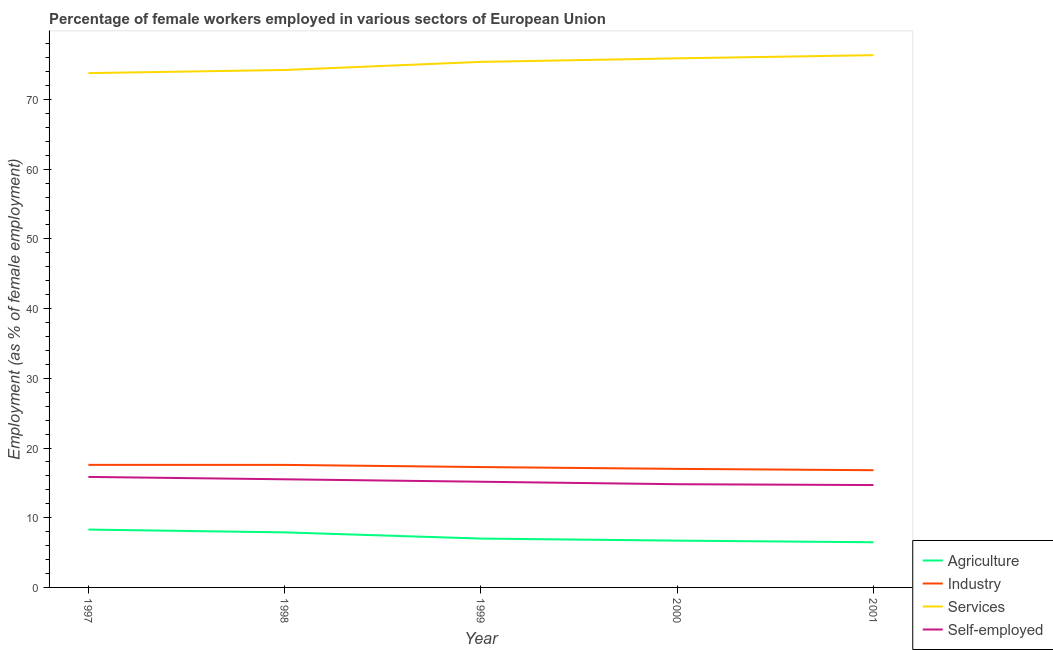How many different coloured lines are there?
Your answer should be very brief. 4. Is the number of lines equal to the number of legend labels?
Provide a succinct answer. Yes. What is the percentage of female workers in agriculture in 1998?
Your answer should be compact. 7.9. Across all years, what is the maximum percentage of female workers in agriculture?
Give a very brief answer. 8.3. Across all years, what is the minimum percentage of female workers in agriculture?
Ensure brevity in your answer.  6.48. In which year was the percentage of female workers in services maximum?
Offer a very short reply. 2001. What is the total percentage of female workers in industry in the graph?
Offer a terse response. 86.25. What is the difference between the percentage of female workers in industry in 1999 and that in 2001?
Offer a terse response. 0.45. What is the difference between the percentage of self employed female workers in 1999 and the percentage of female workers in industry in 1998?
Keep it short and to the point. -2.42. What is the average percentage of female workers in services per year?
Give a very brief answer. 75.13. In the year 1998, what is the difference between the percentage of female workers in services and percentage of self employed female workers?
Offer a terse response. 58.72. In how many years, is the percentage of female workers in agriculture greater than 40 %?
Your answer should be very brief. 0. What is the ratio of the percentage of female workers in agriculture in 1998 to that in 2000?
Make the answer very short. 1.18. Is the percentage of female workers in industry in 1997 less than that in 1999?
Ensure brevity in your answer.  No. Is the difference between the percentage of self employed female workers in 1997 and 2001 greater than the difference between the percentage of female workers in agriculture in 1997 and 2001?
Make the answer very short. No. What is the difference between the highest and the second highest percentage of female workers in industry?
Give a very brief answer. 0. What is the difference between the highest and the lowest percentage of female workers in industry?
Ensure brevity in your answer.  0.76. Is the sum of the percentage of self employed female workers in 1999 and 2001 greater than the maximum percentage of female workers in industry across all years?
Keep it short and to the point. Yes. Is it the case that in every year, the sum of the percentage of self employed female workers and percentage of female workers in agriculture is greater than the sum of percentage of female workers in industry and percentage of female workers in services?
Offer a very short reply. Yes. Is the percentage of female workers in agriculture strictly less than the percentage of self employed female workers over the years?
Provide a short and direct response. Yes. How many lines are there?
Your answer should be very brief. 4. How many years are there in the graph?
Provide a succinct answer. 5. What is the difference between two consecutive major ticks on the Y-axis?
Ensure brevity in your answer.  10. Are the values on the major ticks of Y-axis written in scientific E-notation?
Provide a succinct answer. No. Does the graph contain any zero values?
Your answer should be compact. No. Does the graph contain grids?
Make the answer very short. No. Where does the legend appear in the graph?
Keep it short and to the point. Bottom right. How are the legend labels stacked?
Your response must be concise. Vertical. What is the title of the graph?
Ensure brevity in your answer.  Percentage of female workers employed in various sectors of European Union. Does "Secondary" appear as one of the legend labels in the graph?
Offer a terse response. No. What is the label or title of the X-axis?
Give a very brief answer. Year. What is the label or title of the Y-axis?
Your answer should be compact. Employment (as % of female employment). What is the Employment (as % of female employment) in Agriculture in 1997?
Offer a very short reply. 8.3. What is the Employment (as % of female employment) of Industry in 1997?
Give a very brief answer. 17.58. What is the Employment (as % of female employment) in Services in 1997?
Ensure brevity in your answer.  73.78. What is the Employment (as % of female employment) in Self-employed in 1997?
Make the answer very short. 15.85. What is the Employment (as % of female employment) of Agriculture in 1998?
Provide a succinct answer. 7.9. What is the Employment (as % of female employment) of Industry in 1998?
Offer a terse response. 17.58. What is the Employment (as % of female employment) of Services in 1998?
Give a very brief answer. 74.23. What is the Employment (as % of female employment) of Self-employed in 1998?
Ensure brevity in your answer.  15.51. What is the Employment (as % of female employment) of Agriculture in 1999?
Your response must be concise. 7.01. What is the Employment (as % of female employment) in Industry in 1999?
Your answer should be very brief. 17.27. What is the Employment (as % of female employment) of Services in 1999?
Give a very brief answer. 75.39. What is the Employment (as % of female employment) of Self-employed in 1999?
Ensure brevity in your answer.  15.16. What is the Employment (as % of female employment) of Agriculture in 2000?
Make the answer very short. 6.71. What is the Employment (as % of female employment) of Industry in 2000?
Offer a terse response. 17.01. What is the Employment (as % of female employment) in Services in 2000?
Offer a very short reply. 75.9. What is the Employment (as % of female employment) of Self-employed in 2000?
Make the answer very short. 14.81. What is the Employment (as % of female employment) in Agriculture in 2001?
Provide a succinct answer. 6.48. What is the Employment (as % of female employment) in Industry in 2001?
Ensure brevity in your answer.  16.82. What is the Employment (as % of female employment) of Services in 2001?
Provide a succinct answer. 76.35. What is the Employment (as % of female employment) of Self-employed in 2001?
Your response must be concise. 14.69. Across all years, what is the maximum Employment (as % of female employment) of Agriculture?
Offer a very short reply. 8.3. Across all years, what is the maximum Employment (as % of female employment) in Industry?
Offer a very short reply. 17.58. Across all years, what is the maximum Employment (as % of female employment) of Services?
Ensure brevity in your answer.  76.35. Across all years, what is the maximum Employment (as % of female employment) in Self-employed?
Your answer should be compact. 15.85. Across all years, what is the minimum Employment (as % of female employment) in Agriculture?
Your answer should be very brief. 6.48. Across all years, what is the minimum Employment (as % of female employment) in Industry?
Give a very brief answer. 16.82. Across all years, what is the minimum Employment (as % of female employment) of Services?
Provide a succinct answer. 73.78. Across all years, what is the minimum Employment (as % of female employment) in Self-employed?
Your answer should be very brief. 14.69. What is the total Employment (as % of female employment) in Agriculture in the graph?
Give a very brief answer. 36.4. What is the total Employment (as % of female employment) in Industry in the graph?
Provide a short and direct response. 86.25. What is the total Employment (as % of female employment) in Services in the graph?
Provide a short and direct response. 375.65. What is the total Employment (as % of female employment) of Self-employed in the graph?
Offer a terse response. 76.02. What is the difference between the Employment (as % of female employment) of Agriculture in 1997 and that in 1998?
Keep it short and to the point. 0.4. What is the difference between the Employment (as % of female employment) in Industry in 1997 and that in 1998?
Keep it short and to the point. 0. What is the difference between the Employment (as % of female employment) of Services in 1997 and that in 1998?
Keep it short and to the point. -0.45. What is the difference between the Employment (as % of female employment) in Self-employed in 1997 and that in 1998?
Provide a short and direct response. 0.34. What is the difference between the Employment (as % of female employment) of Agriculture in 1997 and that in 1999?
Give a very brief answer. 1.29. What is the difference between the Employment (as % of female employment) of Industry in 1997 and that in 1999?
Give a very brief answer. 0.32. What is the difference between the Employment (as % of female employment) of Services in 1997 and that in 1999?
Your answer should be very brief. -1.61. What is the difference between the Employment (as % of female employment) of Self-employed in 1997 and that in 1999?
Your answer should be compact. 0.69. What is the difference between the Employment (as % of female employment) in Agriculture in 1997 and that in 2000?
Your answer should be compact. 1.59. What is the difference between the Employment (as % of female employment) of Industry in 1997 and that in 2000?
Offer a terse response. 0.58. What is the difference between the Employment (as % of female employment) of Services in 1997 and that in 2000?
Ensure brevity in your answer.  -2.12. What is the difference between the Employment (as % of female employment) of Self-employed in 1997 and that in 2000?
Keep it short and to the point. 1.05. What is the difference between the Employment (as % of female employment) in Agriculture in 1997 and that in 2001?
Your response must be concise. 1.82. What is the difference between the Employment (as % of female employment) of Industry in 1997 and that in 2001?
Your answer should be very brief. 0.77. What is the difference between the Employment (as % of female employment) in Services in 1997 and that in 2001?
Your response must be concise. -2.57. What is the difference between the Employment (as % of female employment) in Self-employed in 1997 and that in 2001?
Provide a short and direct response. 1.16. What is the difference between the Employment (as % of female employment) of Agriculture in 1998 and that in 1999?
Keep it short and to the point. 0.89. What is the difference between the Employment (as % of female employment) in Industry in 1998 and that in 1999?
Keep it short and to the point. 0.31. What is the difference between the Employment (as % of female employment) of Services in 1998 and that in 1999?
Provide a succinct answer. -1.16. What is the difference between the Employment (as % of female employment) of Self-employed in 1998 and that in 1999?
Your answer should be very brief. 0.35. What is the difference between the Employment (as % of female employment) of Agriculture in 1998 and that in 2000?
Provide a short and direct response. 1.18. What is the difference between the Employment (as % of female employment) in Industry in 1998 and that in 2000?
Your answer should be compact. 0.57. What is the difference between the Employment (as % of female employment) in Services in 1998 and that in 2000?
Your answer should be very brief. -1.67. What is the difference between the Employment (as % of female employment) of Self-employed in 1998 and that in 2000?
Your answer should be very brief. 0.71. What is the difference between the Employment (as % of female employment) of Agriculture in 1998 and that in 2001?
Your answer should be compact. 1.42. What is the difference between the Employment (as % of female employment) of Industry in 1998 and that in 2001?
Your response must be concise. 0.76. What is the difference between the Employment (as % of female employment) in Services in 1998 and that in 2001?
Your answer should be compact. -2.12. What is the difference between the Employment (as % of female employment) in Self-employed in 1998 and that in 2001?
Provide a short and direct response. 0.83. What is the difference between the Employment (as % of female employment) in Agriculture in 1999 and that in 2000?
Your response must be concise. 0.29. What is the difference between the Employment (as % of female employment) in Industry in 1999 and that in 2000?
Provide a short and direct response. 0.26. What is the difference between the Employment (as % of female employment) in Services in 1999 and that in 2000?
Offer a terse response. -0.51. What is the difference between the Employment (as % of female employment) of Self-employed in 1999 and that in 2000?
Offer a terse response. 0.36. What is the difference between the Employment (as % of female employment) of Agriculture in 1999 and that in 2001?
Offer a terse response. 0.53. What is the difference between the Employment (as % of female employment) of Industry in 1999 and that in 2001?
Provide a succinct answer. 0.45. What is the difference between the Employment (as % of female employment) in Services in 1999 and that in 2001?
Offer a terse response. -0.96. What is the difference between the Employment (as % of female employment) in Self-employed in 1999 and that in 2001?
Make the answer very short. 0.48. What is the difference between the Employment (as % of female employment) of Agriculture in 2000 and that in 2001?
Your answer should be compact. 0.23. What is the difference between the Employment (as % of female employment) of Industry in 2000 and that in 2001?
Your answer should be very brief. 0.19. What is the difference between the Employment (as % of female employment) of Services in 2000 and that in 2001?
Ensure brevity in your answer.  -0.45. What is the difference between the Employment (as % of female employment) in Self-employed in 2000 and that in 2001?
Give a very brief answer. 0.12. What is the difference between the Employment (as % of female employment) in Agriculture in 1997 and the Employment (as % of female employment) in Industry in 1998?
Your response must be concise. -9.28. What is the difference between the Employment (as % of female employment) in Agriculture in 1997 and the Employment (as % of female employment) in Services in 1998?
Provide a short and direct response. -65.93. What is the difference between the Employment (as % of female employment) of Agriculture in 1997 and the Employment (as % of female employment) of Self-employed in 1998?
Offer a terse response. -7.21. What is the difference between the Employment (as % of female employment) of Industry in 1997 and the Employment (as % of female employment) of Services in 1998?
Make the answer very short. -56.65. What is the difference between the Employment (as % of female employment) of Industry in 1997 and the Employment (as % of female employment) of Self-employed in 1998?
Keep it short and to the point. 2.07. What is the difference between the Employment (as % of female employment) of Services in 1997 and the Employment (as % of female employment) of Self-employed in 1998?
Offer a terse response. 58.27. What is the difference between the Employment (as % of female employment) in Agriculture in 1997 and the Employment (as % of female employment) in Industry in 1999?
Give a very brief answer. -8.96. What is the difference between the Employment (as % of female employment) in Agriculture in 1997 and the Employment (as % of female employment) in Services in 1999?
Provide a short and direct response. -67.09. What is the difference between the Employment (as % of female employment) of Agriculture in 1997 and the Employment (as % of female employment) of Self-employed in 1999?
Ensure brevity in your answer.  -6.86. What is the difference between the Employment (as % of female employment) in Industry in 1997 and the Employment (as % of female employment) in Services in 1999?
Keep it short and to the point. -57.81. What is the difference between the Employment (as % of female employment) in Industry in 1997 and the Employment (as % of female employment) in Self-employed in 1999?
Keep it short and to the point. 2.42. What is the difference between the Employment (as % of female employment) of Services in 1997 and the Employment (as % of female employment) of Self-employed in 1999?
Offer a terse response. 58.62. What is the difference between the Employment (as % of female employment) of Agriculture in 1997 and the Employment (as % of female employment) of Industry in 2000?
Provide a short and direct response. -8.7. What is the difference between the Employment (as % of female employment) in Agriculture in 1997 and the Employment (as % of female employment) in Services in 2000?
Ensure brevity in your answer.  -67.6. What is the difference between the Employment (as % of female employment) of Agriculture in 1997 and the Employment (as % of female employment) of Self-employed in 2000?
Give a very brief answer. -6.5. What is the difference between the Employment (as % of female employment) in Industry in 1997 and the Employment (as % of female employment) in Services in 2000?
Your response must be concise. -58.32. What is the difference between the Employment (as % of female employment) in Industry in 1997 and the Employment (as % of female employment) in Self-employed in 2000?
Your response must be concise. 2.78. What is the difference between the Employment (as % of female employment) of Services in 1997 and the Employment (as % of female employment) of Self-employed in 2000?
Ensure brevity in your answer.  58.97. What is the difference between the Employment (as % of female employment) in Agriculture in 1997 and the Employment (as % of female employment) in Industry in 2001?
Give a very brief answer. -8.52. What is the difference between the Employment (as % of female employment) in Agriculture in 1997 and the Employment (as % of female employment) in Services in 2001?
Keep it short and to the point. -68.05. What is the difference between the Employment (as % of female employment) of Agriculture in 1997 and the Employment (as % of female employment) of Self-employed in 2001?
Ensure brevity in your answer.  -6.39. What is the difference between the Employment (as % of female employment) in Industry in 1997 and the Employment (as % of female employment) in Services in 2001?
Your answer should be compact. -58.77. What is the difference between the Employment (as % of female employment) in Industry in 1997 and the Employment (as % of female employment) in Self-employed in 2001?
Your response must be concise. 2.9. What is the difference between the Employment (as % of female employment) in Services in 1997 and the Employment (as % of female employment) in Self-employed in 2001?
Give a very brief answer. 59.09. What is the difference between the Employment (as % of female employment) in Agriculture in 1998 and the Employment (as % of female employment) in Industry in 1999?
Your response must be concise. -9.37. What is the difference between the Employment (as % of female employment) in Agriculture in 1998 and the Employment (as % of female employment) in Services in 1999?
Your answer should be very brief. -67.49. What is the difference between the Employment (as % of female employment) of Agriculture in 1998 and the Employment (as % of female employment) of Self-employed in 1999?
Provide a short and direct response. -7.27. What is the difference between the Employment (as % of female employment) of Industry in 1998 and the Employment (as % of female employment) of Services in 1999?
Keep it short and to the point. -57.81. What is the difference between the Employment (as % of female employment) in Industry in 1998 and the Employment (as % of female employment) in Self-employed in 1999?
Provide a short and direct response. 2.42. What is the difference between the Employment (as % of female employment) in Services in 1998 and the Employment (as % of female employment) in Self-employed in 1999?
Your answer should be very brief. 59.07. What is the difference between the Employment (as % of female employment) in Agriculture in 1998 and the Employment (as % of female employment) in Industry in 2000?
Provide a succinct answer. -9.11. What is the difference between the Employment (as % of female employment) of Agriculture in 1998 and the Employment (as % of female employment) of Services in 2000?
Provide a short and direct response. -68. What is the difference between the Employment (as % of female employment) of Agriculture in 1998 and the Employment (as % of female employment) of Self-employed in 2000?
Your answer should be compact. -6.91. What is the difference between the Employment (as % of female employment) of Industry in 1998 and the Employment (as % of female employment) of Services in 2000?
Provide a short and direct response. -58.32. What is the difference between the Employment (as % of female employment) in Industry in 1998 and the Employment (as % of female employment) in Self-employed in 2000?
Ensure brevity in your answer.  2.77. What is the difference between the Employment (as % of female employment) of Services in 1998 and the Employment (as % of female employment) of Self-employed in 2000?
Your response must be concise. 59.42. What is the difference between the Employment (as % of female employment) of Agriculture in 1998 and the Employment (as % of female employment) of Industry in 2001?
Provide a short and direct response. -8.92. What is the difference between the Employment (as % of female employment) in Agriculture in 1998 and the Employment (as % of female employment) in Services in 2001?
Ensure brevity in your answer.  -68.46. What is the difference between the Employment (as % of female employment) in Agriculture in 1998 and the Employment (as % of female employment) in Self-employed in 2001?
Offer a terse response. -6.79. What is the difference between the Employment (as % of female employment) of Industry in 1998 and the Employment (as % of female employment) of Services in 2001?
Provide a succinct answer. -58.77. What is the difference between the Employment (as % of female employment) of Industry in 1998 and the Employment (as % of female employment) of Self-employed in 2001?
Your answer should be compact. 2.89. What is the difference between the Employment (as % of female employment) of Services in 1998 and the Employment (as % of female employment) of Self-employed in 2001?
Offer a terse response. 59.54. What is the difference between the Employment (as % of female employment) of Agriculture in 1999 and the Employment (as % of female employment) of Industry in 2000?
Ensure brevity in your answer.  -10. What is the difference between the Employment (as % of female employment) in Agriculture in 1999 and the Employment (as % of female employment) in Services in 2000?
Provide a succinct answer. -68.89. What is the difference between the Employment (as % of female employment) of Agriculture in 1999 and the Employment (as % of female employment) of Self-employed in 2000?
Offer a terse response. -7.8. What is the difference between the Employment (as % of female employment) in Industry in 1999 and the Employment (as % of female employment) in Services in 2000?
Ensure brevity in your answer.  -58.63. What is the difference between the Employment (as % of female employment) of Industry in 1999 and the Employment (as % of female employment) of Self-employed in 2000?
Provide a succinct answer. 2.46. What is the difference between the Employment (as % of female employment) of Services in 1999 and the Employment (as % of female employment) of Self-employed in 2000?
Ensure brevity in your answer.  60.59. What is the difference between the Employment (as % of female employment) of Agriculture in 1999 and the Employment (as % of female employment) of Industry in 2001?
Offer a very short reply. -9.81. What is the difference between the Employment (as % of female employment) in Agriculture in 1999 and the Employment (as % of female employment) in Services in 2001?
Provide a short and direct response. -69.35. What is the difference between the Employment (as % of female employment) of Agriculture in 1999 and the Employment (as % of female employment) of Self-employed in 2001?
Give a very brief answer. -7.68. What is the difference between the Employment (as % of female employment) in Industry in 1999 and the Employment (as % of female employment) in Services in 2001?
Provide a short and direct response. -59.09. What is the difference between the Employment (as % of female employment) of Industry in 1999 and the Employment (as % of female employment) of Self-employed in 2001?
Provide a succinct answer. 2.58. What is the difference between the Employment (as % of female employment) in Services in 1999 and the Employment (as % of female employment) in Self-employed in 2001?
Make the answer very short. 60.7. What is the difference between the Employment (as % of female employment) of Agriculture in 2000 and the Employment (as % of female employment) of Industry in 2001?
Ensure brevity in your answer.  -10.1. What is the difference between the Employment (as % of female employment) in Agriculture in 2000 and the Employment (as % of female employment) in Services in 2001?
Provide a short and direct response. -69.64. What is the difference between the Employment (as % of female employment) of Agriculture in 2000 and the Employment (as % of female employment) of Self-employed in 2001?
Ensure brevity in your answer.  -7.97. What is the difference between the Employment (as % of female employment) in Industry in 2000 and the Employment (as % of female employment) in Services in 2001?
Give a very brief answer. -59.35. What is the difference between the Employment (as % of female employment) in Industry in 2000 and the Employment (as % of female employment) in Self-employed in 2001?
Give a very brief answer. 2.32. What is the difference between the Employment (as % of female employment) in Services in 2000 and the Employment (as % of female employment) in Self-employed in 2001?
Your answer should be compact. 61.21. What is the average Employment (as % of female employment) in Agriculture per year?
Provide a short and direct response. 7.28. What is the average Employment (as % of female employment) in Industry per year?
Your answer should be very brief. 17.25. What is the average Employment (as % of female employment) in Services per year?
Your response must be concise. 75.13. What is the average Employment (as % of female employment) in Self-employed per year?
Your answer should be very brief. 15.2. In the year 1997, what is the difference between the Employment (as % of female employment) of Agriculture and Employment (as % of female employment) of Industry?
Keep it short and to the point. -9.28. In the year 1997, what is the difference between the Employment (as % of female employment) in Agriculture and Employment (as % of female employment) in Services?
Your response must be concise. -65.48. In the year 1997, what is the difference between the Employment (as % of female employment) in Agriculture and Employment (as % of female employment) in Self-employed?
Your response must be concise. -7.55. In the year 1997, what is the difference between the Employment (as % of female employment) of Industry and Employment (as % of female employment) of Services?
Provide a succinct answer. -56.2. In the year 1997, what is the difference between the Employment (as % of female employment) of Industry and Employment (as % of female employment) of Self-employed?
Your answer should be compact. 1.73. In the year 1997, what is the difference between the Employment (as % of female employment) of Services and Employment (as % of female employment) of Self-employed?
Offer a very short reply. 57.93. In the year 1998, what is the difference between the Employment (as % of female employment) of Agriculture and Employment (as % of female employment) of Industry?
Ensure brevity in your answer.  -9.68. In the year 1998, what is the difference between the Employment (as % of female employment) of Agriculture and Employment (as % of female employment) of Services?
Your answer should be very brief. -66.33. In the year 1998, what is the difference between the Employment (as % of female employment) in Agriculture and Employment (as % of female employment) in Self-employed?
Make the answer very short. -7.62. In the year 1998, what is the difference between the Employment (as % of female employment) in Industry and Employment (as % of female employment) in Services?
Your answer should be compact. -56.65. In the year 1998, what is the difference between the Employment (as % of female employment) of Industry and Employment (as % of female employment) of Self-employed?
Provide a short and direct response. 2.07. In the year 1998, what is the difference between the Employment (as % of female employment) in Services and Employment (as % of female employment) in Self-employed?
Provide a short and direct response. 58.72. In the year 1999, what is the difference between the Employment (as % of female employment) of Agriculture and Employment (as % of female employment) of Industry?
Provide a short and direct response. -10.26. In the year 1999, what is the difference between the Employment (as % of female employment) of Agriculture and Employment (as % of female employment) of Services?
Make the answer very short. -68.38. In the year 1999, what is the difference between the Employment (as % of female employment) in Agriculture and Employment (as % of female employment) in Self-employed?
Your answer should be compact. -8.16. In the year 1999, what is the difference between the Employment (as % of female employment) of Industry and Employment (as % of female employment) of Services?
Offer a very short reply. -58.13. In the year 1999, what is the difference between the Employment (as % of female employment) of Industry and Employment (as % of female employment) of Self-employed?
Your answer should be very brief. 2.1. In the year 1999, what is the difference between the Employment (as % of female employment) in Services and Employment (as % of female employment) in Self-employed?
Keep it short and to the point. 60.23. In the year 2000, what is the difference between the Employment (as % of female employment) of Agriculture and Employment (as % of female employment) of Industry?
Offer a terse response. -10.29. In the year 2000, what is the difference between the Employment (as % of female employment) in Agriculture and Employment (as % of female employment) in Services?
Provide a short and direct response. -69.18. In the year 2000, what is the difference between the Employment (as % of female employment) of Agriculture and Employment (as % of female employment) of Self-employed?
Keep it short and to the point. -8.09. In the year 2000, what is the difference between the Employment (as % of female employment) in Industry and Employment (as % of female employment) in Services?
Your answer should be compact. -58.89. In the year 2000, what is the difference between the Employment (as % of female employment) of Industry and Employment (as % of female employment) of Self-employed?
Your answer should be very brief. 2.2. In the year 2000, what is the difference between the Employment (as % of female employment) in Services and Employment (as % of female employment) in Self-employed?
Give a very brief answer. 61.09. In the year 2001, what is the difference between the Employment (as % of female employment) in Agriculture and Employment (as % of female employment) in Industry?
Provide a short and direct response. -10.34. In the year 2001, what is the difference between the Employment (as % of female employment) of Agriculture and Employment (as % of female employment) of Services?
Keep it short and to the point. -69.87. In the year 2001, what is the difference between the Employment (as % of female employment) of Agriculture and Employment (as % of female employment) of Self-employed?
Offer a very short reply. -8.21. In the year 2001, what is the difference between the Employment (as % of female employment) of Industry and Employment (as % of female employment) of Services?
Offer a very short reply. -59.54. In the year 2001, what is the difference between the Employment (as % of female employment) of Industry and Employment (as % of female employment) of Self-employed?
Offer a very short reply. 2.13. In the year 2001, what is the difference between the Employment (as % of female employment) of Services and Employment (as % of female employment) of Self-employed?
Give a very brief answer. 61.67. What is the ratio of the Employment (as % of female employment) in Agriculture in 1997 to that in 1998?
Give a very brief answer. 1.05. What is the ratio of the Employment (as % of female employment) of Industry in 1997 to that in 1998?
Offer a terse response. 1. What is the ratio of the Employment (as % of female employment) in Services in 1997 to that in 1998?
Provide a succinct answer. 0.99. What is the ratio of the Employment (as % of female employment) in Self-employed in 1997 to that in 1998?
Provide a succinct answer. 1.02. What is the ratio of the Employment (as % of female employment) in Agriculture in 1997 to that in 1999?
Your answer should be compact. 1.18. What is the ratio of the Employment (as % of female employment) of Industry in 1997 to that in 1999?
Offer a very short reply. 1.02. What is the ratio of the Employment (as % of female employment) of Services in 1997 to that in 1999?
Provide a succinct answer. 0.98. What is the ratio of the Employment (as % of female employment) in Self-employed in 1997 to that in 1999?
Ensure brevity in your answer.  1.05. What is the ratio of the Employment (as % of female employment) of Agriculture in 1997 to that in 2000?
Keep it short and to the point. 1.24. What is the ratio of the Employment (as % of female employment) in Industry in 1997 to that in 2000?
Ensure brevity in your answer.  1.03. What is the ratio of the Employment (as % of female employment) of Services in 1997 to that in 2000?
Ensure brevity in your answer.  0.97. What is the ratio of the Employment (as % of female employment) in Self-employed in 1997 to that in 2000?
Make the answer very short. 1.07. What is the ratio of the Employment (as % of female employment) of Agriculture in 1997 to that in 2001?
Your answer should be very brief. 1.28. What is the ratio of the Employment (as % of female employment) in Industry in 1997 to that in 2001?
Ensure brevity in your answer.  1.05. What is the ratio of the Employment (as % of female employment) in Services in 1997 to that in 2001?
Your response must be concise. 0.97. What is the ratio of the Employment (as % of female employment) in Self-employed in 1997 to that in 2001?
Offer a very short reply. 1.08. What is the ratio of the Employment (as % of female employment) of Agriculture in 1998 to that in 1999?
Provide a short and direct response. 1.13. What is the ratio of the Employment (as % of female employment) of Industry in 1998 to that in 1999?
Give a very brief answer. 1.02. What is the ratio of the Employment (as % of female employment) in Services in 1998 to that in 1999?
Keep it short and to the point. 0.98. What is the ratio of the Employment (as % of female employment) of Self-employed in 1998 to that in 1999?
Ensure brevity in your answer.  1.02. What is the ratio of the Employment (as % of female employment) of Agriculture in 1998 to that in 2000?
Your response must be concise. 1.18. What is the ratio of the Employment (as % of female employment) of Industry in 1998 to that in 2000?
Make the answer very short. 1.03. What is the ratio of the Employment (as % of female employment) of Services in 1998 to that in 2000?
Provide a succinct answer. 0.98. What is the ratio of the Employment (as % of female employment) in Self-employed in 1998 to that in 2000?
Give a very brief answer. 1.05. What is the ratio of the Employment (as % of female employment) of Agriculture in 1998 to that in 2001?
Provide a succinct answer. 1.22. What is the ratio of the Employment (as % of female employment) of Industry in 1998 to that in 2001?
Provide a short and direct response. 1.05. What is the ratio of the Employment (as % of female employment) in Services in 1998 to that in 2001?
Your answer should be compact. 0.97. What is the ratio of the Employment (as % of female employment) of Self-employed in 1998 to that in 2001?
Offer a terse response. 1.06. What is the ratio of the Employment (as % of female employment) in Agriculture in 1999 to that in 2000?
Provide a succinct answer. 1.04. What is the ratio of the Employment (as % of female employment) of Industry in 1999 to that in 2000?
Ensure brevity in your answer.  1.02. What is the ratio of the Employment (as % of female employment) in Self-employed in 1999 to that in 2000?
Keep it short and to the point. 1.02. What is the ratio of the Employment (as % of female employment) in Agriculture in 1999 to that in 2001?
Your answer should be compact. 1.08. What is the ratio of the Employment (as % of female employment) in Industry in 1999 to that in 2001?
Your response must be concise. 1.03. What is the ratio of the Employment (as % of female employment) of Services in 1999 to that in 2001?
Your answer should be compact. 0.99. What is the ratio of the Employment (as % of female employment) in Self-employed in 1999 to that in 2001?
Make the answer very short. 1.03. What is the ratio of the Employment (as % of female employment) of Agriculture in 2000 to that in 2001?
Provide a short and direct response. 1.04. What is the ratio of the Employment (as % of female employment) of Industry in 2000 to that in 2001?
Make the answer very short. 1.01. What is the ratio of the Employment (as % of female employment) in Services in 2000 to that in 2001?
Your answer should be very brief. 0.99. What is the difference between the highest and the second highest Employment (as % of female employment) of Agriculture?
Offer a very short reply. 0.4. What is the difference between the highest and the second highest Employment (as % of female employment) of Industry?
Make the answer very short. 0. What is the difference between the highest and the second highest Employment (as % of female employment) of Services?
Provide a succinct answer. 0.45. What is the difference between the highest and the second highest Employment (as % of female employment) in Self-employed?
Give a very brief answer. 0.34. What is the difference between the highest and the lowest Employment (as % of female employment) in Agriculture?
Make the answer very short. 1.82. What is the difference between the highest and the lowest Employment (as % of female employment) in Industry?
Keep it short and to the point. 0.77. What is the difference between the highest and the lowest Employment (as % of female employment) of Services?
Your answer should be very brief. 2.57. What is the difference between the highest and the lowest Employment (as % of female employment) of Self-employed?
Ensure brevity in your answer.  1.16. 